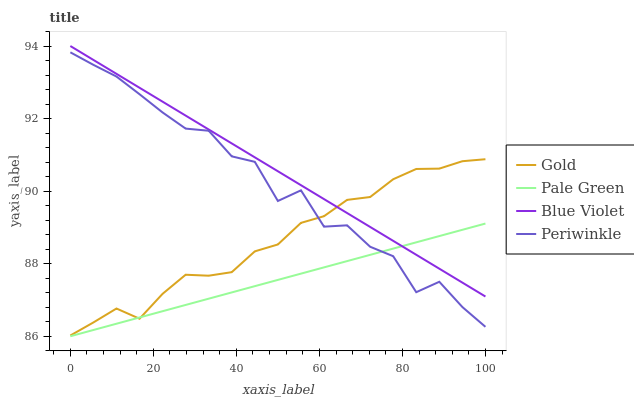Does Pale Green have the minimum area under the curve?
Answer yes or no. Yes. Does Blue Violet have the maximum area under the curve?
Answer yes or no. Yes. Does Periwinkle have the minimum area under the curve?
Answer yes or no. No. Does Periwinkle have the maximum area under the curve?
Answer yes or no. No. Is Blue Violet the smoothest?
Answer yes or no. Yes. Is Periwinkle the roughest?
Answer yes or no. Yes. Is Periwinkle the smoothest?
Answer yes or no. No. Is Blue Violet the roughest?
Answer yes or no. No. Does Periwinkle have the lowest value?
Answer yes or no. No. Does Blue Violet have the highest value?
Answer yes or no. Yes. Does Periwinkle have the highest value?
Answer yes or no. No. Is Periwinkle less than Blue Violet?
Answer yes or no. Yes. Is Blue Violet greater than Periwinkle?
Answer yes or no. Yes. Does Periwinkle intersect Blue Violet?
Answer yes or no. No. 